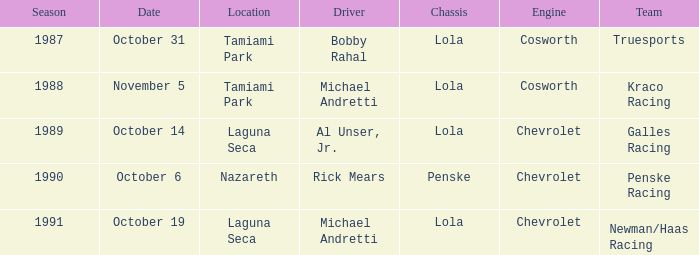Which team raced on October 19? Newman/Haas Racing. 